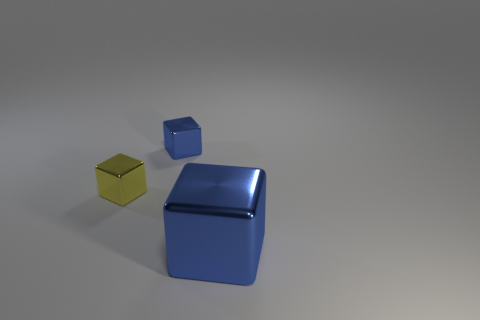Is there a blue metallic block?
Your answer should be very brief. Yes. There is a small block that is the same color as the big thing; what is it made of?
Your answer should be very brief. Metal. How many objects are either big objects or tiny metal objects?
Give a very brief answer. 3. Is there a cube that has the same color as the large thing?
Make the answer very short. Yes. There is a block that is behind the small yellow thing; how many small blue things are on the left side of it?
Give a very brief answer. 0. Are there more matte cylinders than big blue shiny blocks?
Your answer should be compact. No. Does the yellow object have the same material as the big block?
Make the answer very short. Yes. Are there an equal number of tiny blue metallic things in front of the tiny blue cube and yellow metallic blocks?
Offer a very short reply. No. What number of small objects are the same material as the big thing?
Provide a short and direct response. 2. Is the number of purple rubber objects less than the number of big things?
Your answer should be very brief. Yes. 